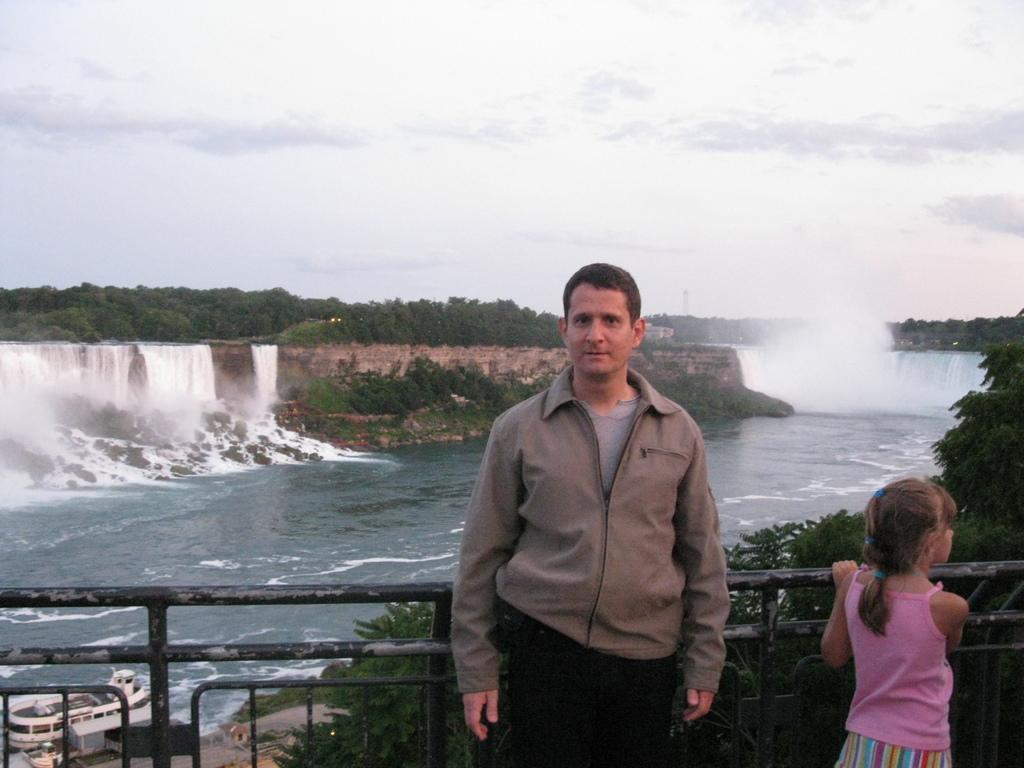What can be seen in the background of the image? In the background of the image, there is a sky, trees, and a waterfall. What is the primary element visible in the image? Water is the primary element visible in the image. What type of vehicle is present in the image? There is a ship in the image. What objects are present in the image? There are objects in the image, but their specific nature is not mentioned in the facts. What is the man wearing in the image? The man is wearing a jacket in the image. Who else is present in the image? There is also a girl in the image. What type of knot is the laborer using to secure the window in the image? There is no laborer, window, or knot present in the image. 